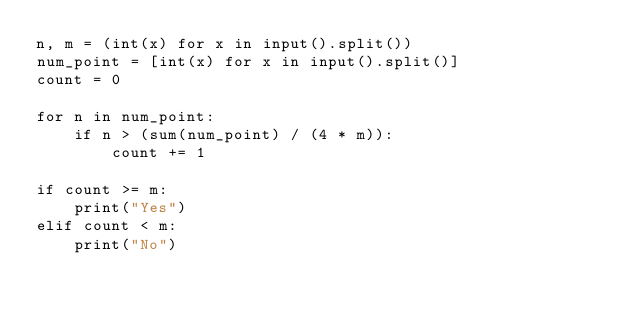<code> <loc_0><loc_0><loc_500><loc_500><_Python_>n, m = (int(x) for x in input().split())
num_point = [int(x) for x in input().split()]
count = 0

for n in num_point:
    if n > (sum(num_point) / (4 * m)):
        count += 1

if count >= m:
    print("Yes")
elif count < m:
    print("No")
</code> 